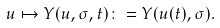<formula> <loc_0><loc_0><loc_500><loc_500>u \mapsto Y ( u , \sigma , t ) \colon = Y ( u ( t ) , \sigma ) .</formula> 